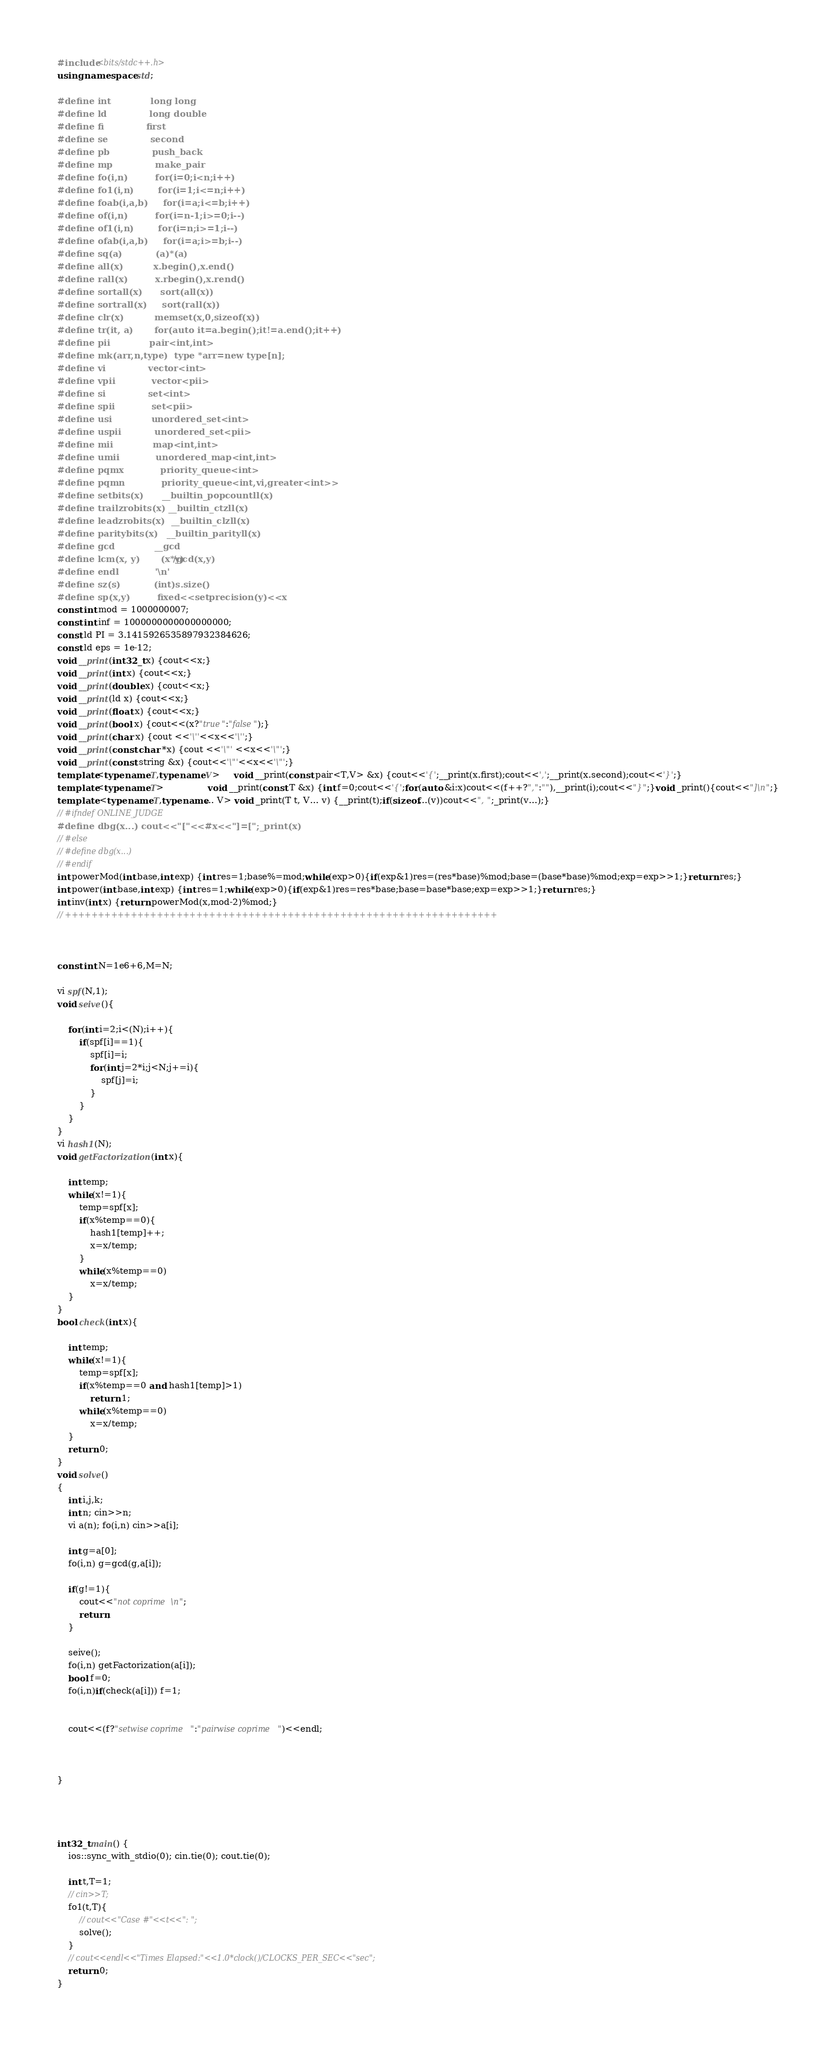Convert code to text. <code><loc_0><loc_0><loc_500><loc_500><_C++_>#include<bits/stdc++.h>
using namespace std;

#define int             long long
#define ld              long double
#define fi              first
#define se              second
#define pb              push_back
#define mp              make_pair
#define fo(i,n)         for(i=0;i<n;i++)
#define fo1(i,n)        for(i=1;i<=n;i++)
#define foab(i,a,b)     for(i=a;i<=b;i++)
#define of(i,n)         for(i=n-1;i>=0;i--)
#define of1(i,n)        for(i=n;i>=1;i--)
#define ofab(i,a,b)     for(i=a;i>=b;i--)
#define sq(a)           (a)*(a)
#define all(x)          x.begin(),x.end()
#define rall(x)         x.rbegin(),x.rend()
#define sortall(x)      sort(all(x))
#define sortrall(x)     sort(rall(x))
#define clr(x)          memset(x,0,sizeof(x))
#define tr(it, a)       for(auto it=a.begin();it!=a.end();it++)
#define pii             pair<int,int>
#define mk(arr,n,type)  type *arr=new type[n];
#define vi              vector<int>
#define vpii            vector<pii>
#define si              set<int>
#define spii            set<pii>
#define usi             unordered_set<int>
#define uspii           unordered_set<pii>
#define mii             map<int,int>
#define umii            unordered_map<int,int>
#define pqmx            priority_queue<int>
#define pqmn            priority_queue<int,vi,greater<int>>
#define setbits(x)      __builtin_popcountll(x)
#define trailzrobits(x) __builtin_ctzll(x)
#define leadzrobits(x)  __builtin_clzll(x)
#define paritybits(x)   __builtin_parityll(x)
#define gcd             __gcd
#define lcm(x, y)       (x*y)/gcd(x,y)
#define endl            '\n'
#define sz(s)           (int)s.size()
#define sp(x,y)         fixed<<setprecision(y)<<x
const int mod = 1000000007;
const int inf = 1000000000000000000;
const ld PI = 3.1415926535897932384626;
const ld eps = 1e-12;
void __print(int32_t x) {cout<<x;}
void __print(int x) {cout<<x;}
void __print(double x) {cout<<x;}
void __print(ld x) {cout<<x;}
void __print(float x) {cout<<x;}
void __print(bool x) {cout<<(x?"true":"false");}
void __print(char x) {cout <<'\''<<x<<'\'';}
void __print(const char *x) {cout <<'\"' <<x<<'\"';}
void __print(const string &x) {cout<<'\"'<<x<<'\"';}
template<typename T,typename V>     void __print(const pair<T,V> &x) {cout<<'{';__print(x.first);cout<<',';__print(x.second);cout<<'}';}
template<typename T>                void __print(const T &x) {int f=0;cout<<'{';for(auto &i:x)cout<<(f++?",":""),__print(i);cout<<"}";}void _print(){cout<<"]\n";}
template <typename T,typename... V> void _print(T t, V... v) {__print(t);if(sizeof...(v))cout<<", ";_print(v...);}
// #ifndef ONLINE_JUDGE
#define dbg(x...) cout<<"["<<#x<<"]=[";_print(x)
// #else 
// #define dbg(x...)
// #endif
int powerMod(int base,int exp) {int res=1;base%=mod;while(exp>0){if(exp&1)res=(res*base)%mod;base=(base*base)%mod;exp=exp>>1;}return res;}
int power(int base,int exp) {int res=1;while(exp>0){if(exp&1)res=res*base;base=base*base;exp=exp>>1;}return res;}
int inv(int x) {return powerMod(x,mod-2)%mod;}
// ++++++++++++++++++++++++++++++++++++++++++++++++++++++++++++++++++



const int N=1e6+6,M=N;

vi spf(N,1);
void seive(){
    
    for(int i=2;i<(N);i++){
        if(spf[i]==1){
            spf[i]=i;
            for(int j=2*i;j<N;j+=i){
                spf[j]=i;
            }
        }
    }
}
vi hash1(N);
void getFactorization(int x){

    int temp; 
    while(x!=1){ 
        temp=spf[x]; 
        if(x%temp==0){  
            hash1[temp]++; 
            x=x/temp; 
        } 
        while(x%temp==0) 
            x=x/temp; 
    } 
} 
bool check(int x){

    int temp; 
    while(x!=1){ 
        temp=spf[x]; 
        if(x%temp==0 and hash1[temp]>1) 
            return 1; 
        while(x%temp==0) 
            x=x/temp; 
    } 
    return 0; 
}
void solve()
{   
    int i,j,k;
    int n; cin>>n;
    vi a(n); fo(i,n) cin>>a[i];

    int g=a[0];
    fo(i,n) g=gcd(g,a[i]);
    
    if(g!=1){
        cout<<"not coprime\n";
        return;
    }

    seive();
    fo(i,n) getFactorization(a[i]);
    bool f=0;
    fo(i,n)if(check(a[i])) f=1;
 
    
    cout<<(f?"setwise coprime":"pairwise coprime")<<endl;



}




int32_t main() {
    ios::sync_with_stdio(0); cin.tie(0); cout.tie(0);
    
    int t,T=1;
    // cin>>T;
    fo1(t,T){
        // cout<<"Case #"<<t<<": ";
        solve();
    }
    // cout<<endl<<"Times Elapsed:"<<1.0*clock()/CLOCKS_PER_SEC<<"sec";
    return 0;
}</code> 